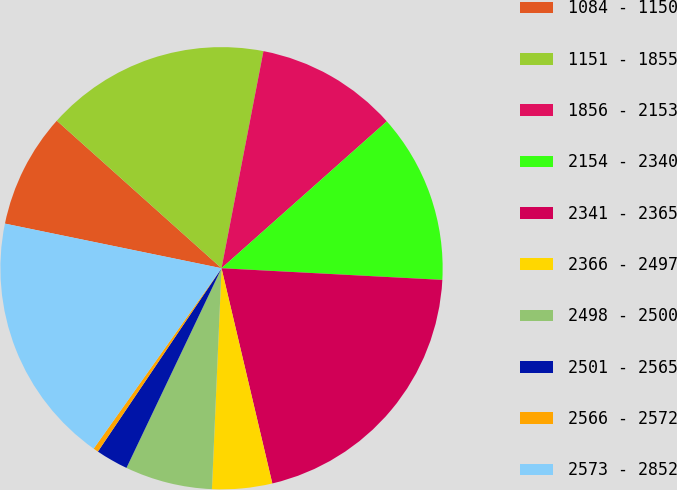<chart> <loc_0><loc_0><loc_500><loc_500><pie_chart><fcel>1084 - 1150<fcel>1151 - 1855<fcel>1856 - 2153<fcel>2154 - 2340<fcel>2341 - 2365<fcel>2366 - 2497<fcel>2498 - 2500<fcel>2501 - 2565<fcel>2566 - 2572<fcel>2573 - 2852<nl><fcel>8.39%<fcel>16.41%<fcel>10.4%<fcel>12.4%<fcel>20.47%<fcel>4.38%<fcel>6.38%<fcel>2.37%<fcel>0.37%<fcel>18.42%<nl></chart> 